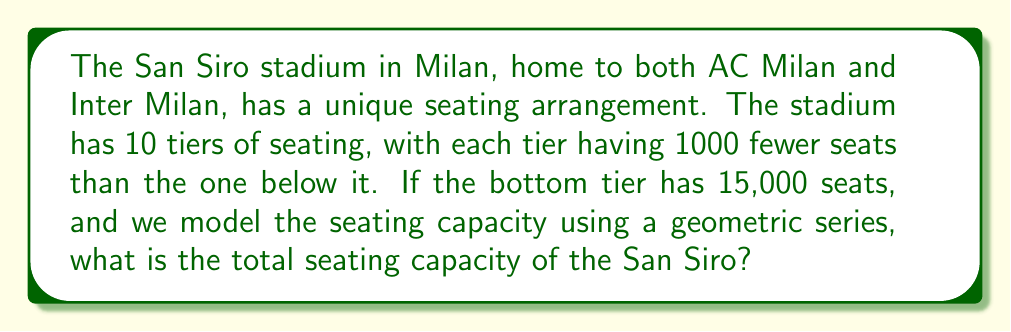Can you solve this math problem? Let's approach this problem step-by-step using the concept of geometric series:

1) First, we need to identify the terms of our geometric series:
   - $a_1 = 15000$ (first term, bottom tier)
   - $r = \frac{14000}{15000} = \frac{14}{15}$ (common ratio)
   - $n = 10$ (number of terms, tiers)

2) The formula for the sum of a geometric series is:

   $$S_n = \frac{a_1(1-r^n)}{1-r}$$

   Where $S_n$ is the sum of the series, $a_1$ is the first term, $r$ is the common ratio, and $n$ is the number of terms.

3) Let's substitute our values:

   $$S_{10} = \frac{15000(1-(\frac{14}{15})^{10})}{1-\frac{14}{15}}$$

4) Simplify:
   $$S_{10} = \frac{15000(1-(\frac{14}{15})^{10})}{\frac{1}{15}}$$

   $$S_{10} = 225000(1-(\frac{14}{15})^{10})$$

5) Calculate $(\frac{14}{15})^{10}$:
   $$(\frac{14}{15})^{10} \approx 0.5188$$

6) Substitute back:
   $$S_{10} = 225000(1-0.5188)$$
   $$S_{10} = 225000(0.4812)$$
   $$S_{10} = 108,270$$

7) Round to the nearest whole number as we can't have partial seats:
   $$S_{10} \approx 108,270$$

Therefore, the total seating capacity of the San Siro stadium is approximately 108,270.
Answer: The total seating capacity of the San Siro stadium is approximately 108,270 seats. 